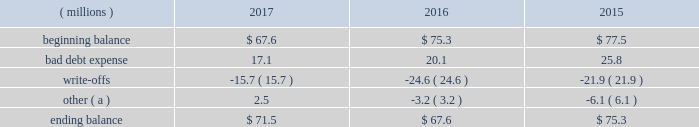Cash and cash equivalents cash equivalents include highly-liquid investments with a maturity of three months or less when purchased .
Accounts receivable and allowance for doubtful accounts accounts receivable are carried at the invoiced amounts , less an allowance for doubtful accounts , and generally do not bear interest .
The company estimates the balance of allowance for doubtful accounts by analyzing accounts receivable balances by age and applying historical write-off and collection trend rates .
The company 2019s estimates include separately providing for customer receivables based on specific circumstances and credit conditions , and when it is deemed probable that the balance is uncollectible .
Account balances are written off against the allowance when it is determined the receivable will not be recovered .
The company 2019s allowance for doubtful accounts balance also includes an allowance for the expected return of products shipped and credits related to pricing or quantities shipped of $ 15 million , $ 14 million and $ 15 million as of december 31 , 2017 , 2016 , and 2015 , respectively .
Returns and credit activity is recorded directly to sales as a reduction .
The table summarizes the activity in the allowance for doubtful accounts: .
( a ) other amounts are primarily the effects of changes in currency translations and the impact of allowance for returns and credits .
Inventory valuations inventories are valued at the lower of cost or net realizable value .
Certain u.s .
Inventory costs are determined on a last-in , first-out ( 201clifo 201d ) basis .
Lifo inventories represented 39% ( 39 % ) and 40% ( 40 % ) of consolidated inventories as of december 31 , 2017 and 2016 , respectively .
All other inventory costs are determined using either the average cost or first-in , first-out ( 201cfifo 201d ) methods .
Inventory values at fifo , as shown in note 5 , approximate replacement cost .
Property , plant and equipment property , plant and equipment assets are stated at cost .
Merchandising and customer equipment consists principally of various dispensing systems for the company 2019s cleaning and sanitizing products , dishwashing machines and process control and monitoring equipment .
Certain dispensing systems capitalized by the company are accounted for on a mass asset basis , whereby equipment is capitalized and depreciated as a group and written off when fully depreciated .
The company capitalizes both internal and external costs of development or purchase of computer software for internal use .
Costs incurred for data conversion , training and maintenance associated with capitalized software are expensed as incurred .
Expenditures for major renewals and improvements , which significantly extend the useful lives of existing plant and equipment , are capitalized and depreciated .
Expenditures for repairs and maintenance are charged to expense as incurred .
Upon retirement or disposition of plant and equipment , the cost and related accumulated depreciation are removed from the accounts and any resulting gain or loss is recognized in income .
Depreciation is charged to operations using the straight-line method over the assets 2019 estimated useful lives ranging from 5 to 40 years for buildings and leasehold improvements , 3 to 20 years for machinery and equipment , 3 to 15 years for merchandising and customer equipment and 3 to 7 years for capitalized software .
The straight-line method of depreciation reflects an appropriate allocation of the cost of the assets to earnings in proportion to the amount of economic benefits obtained by the company in each reporting period .
Depreciation expense was $ 586 million , $ 561 million and $ 560 million for 2017 , 2016 and 2015 , respectively. .
What is the net change in the balance of allowance for doubtful accounts from 2016 to 2017? 
Computations: (71.5 - 67.6)
Answer: 3.9. 